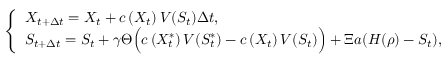Convert formula to latex. <formula><loc_0><loc_0><loc_500><loc_500>\left \{ \begin{array} { l l } { X _ { t + \Delta { t } } = X _ { t } + c \left ( X _ { t } \right ) V ( S _ { t } ) \Delta { t } , \quad } \\ { S _ { t + \Delta { t } } = S _ { t } + \gamma \Theta \left ( c \left ( X _ { t } ^ { \ast } \right ) V ( S _ { t } ^ { \ast } ) - c \left ( X _ { t } \right ) V ( S _ { t } ) \right ) + \Xi a ( H ( \rho ) - S _ { t } ) , } \end{array}</formula> 